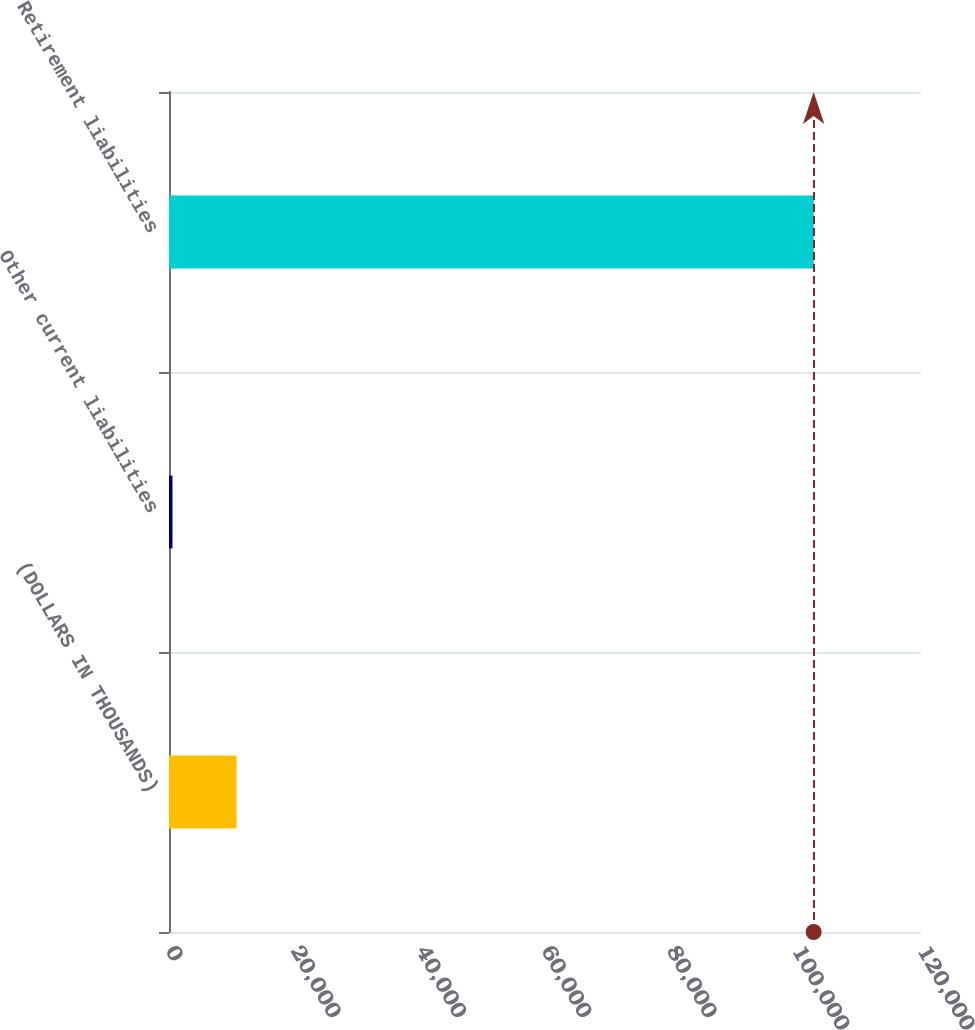Convert chart to OTSL. <chart><loc_0><loc_0><loc_500><loc_500><bar_chart><fcel>(DOLLARS IN THOUSANDS)<fcel>Other current liabilities<fcel>Retirement liabilities<nl><fcel>10788.4<fcel>557<fcel>102871<nl></chart> 